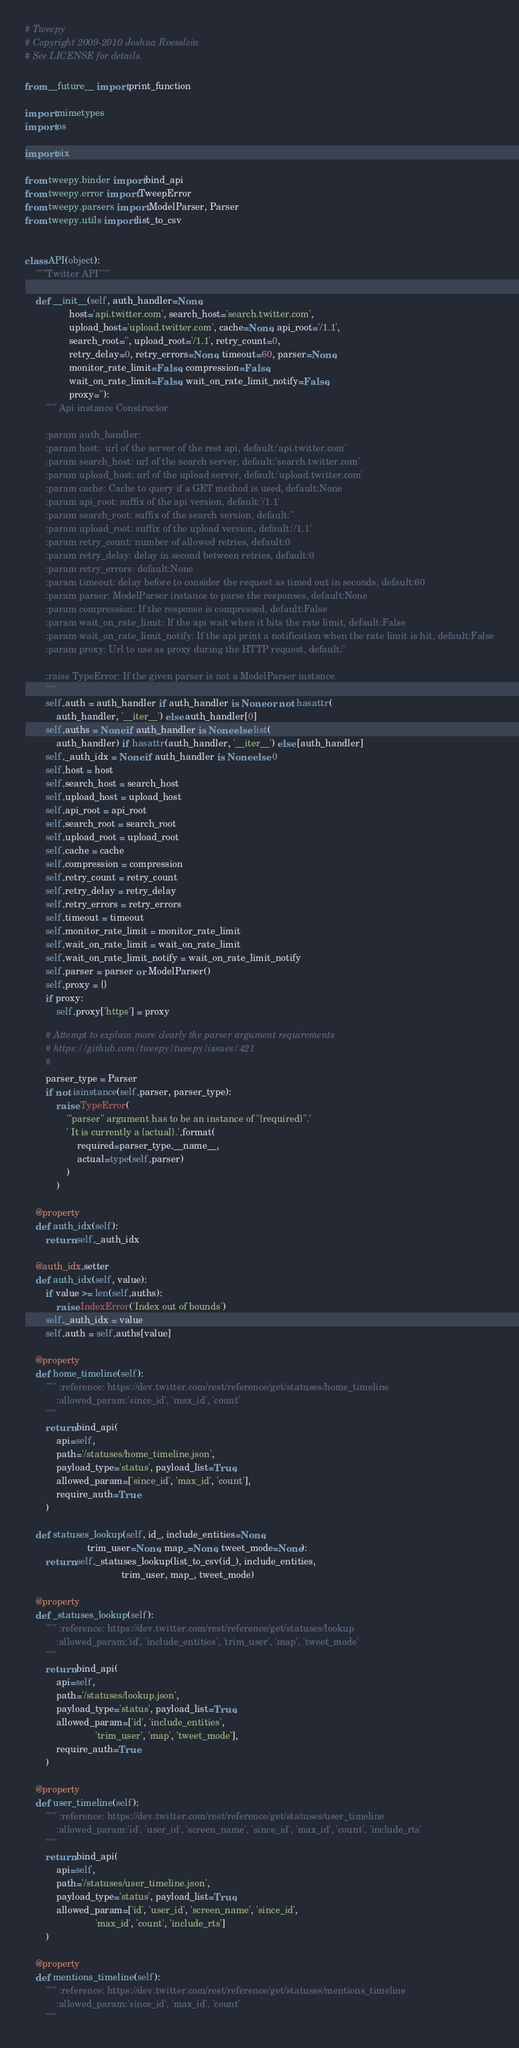<code> <loc_0><loc_0><loc_500><loc_500><_Python_># Tweepy
# Copyright 2009-2010 Joshua Roesslein
# See LICENSE for details.

from __future__ import print_function

import mimetypes
import os

import six

from tweepy.binder import bind_api
from tweepy.error import TweepError
from tweepy.parsers import ModelParser, Parser
from tweepy.utils import list_to_csv


class API(object):
    """Twitter API"""

    def __init__(self, auth_handler=None,
                 host='api.twitter.com', search_host='search.twitter.com',
                 upload_host='upload.twitter.com', cache=None, api_root='/1.1',
                 search_root='', upload_root='/1.1', retry_count=0,
                 retry_delay=0, retry_errors=None, timeout=60, parser=None,
                 monitor_rate_limit=False, compression=False,
                 wait_on_rate_limit=False, wait_on_rate_limit_notify=False,
                 proxy=''):
        """ Api instance Constructor

        :param auth_handler:
        :param host:  url of the server of the rest api, default:'api.twitter.com'
        :param search_host: url of the search server, default:'search.twitter.com'
        :param upload_host: url of the upload server, default:'upload.twitter.com'
        :param cache: Cache to query if a GET method is used, default:None
        :param api_root: suffix of the api version, default:'/1.1'
        :param search_root: suffix of the search version, default:''
        :param upload_root: suffix of the upload version, default:'/1.1'
        :param retry_count: number of allowed retries, default:0
        :param retry_delay: delay in second between retries, default:0
        :param retry_errors: default:None
        :param timeout: delay before to consider the request as timed out in seconds, default:60
        :param parser: ModelParser instance to parse the responses, default:None
        :param compression: If the response is compressed, default:False
        :param wait_on_rate_limit: If the api wait when it hits the rate limit, default:False
        :param wait_on_rate_limit_notify: If the api print a notification when the rate limit is hit, default:False
        :param proxy: Url to use as proxy during the HTTP request, default:''

        :raise TypeError: If the given parser is not a ModelParser instance.
        """
        self.auth = auth_handler if auth_handler is None or not hasattr(
            auth_handler, '__iter__') else auth_handler[0]
        self.auths = None if auth_handler is None else list(
            auth_handler) if hasattr(auth_handler, '__iter__') else [auth_handler]
        self._auth_idx = None if auth_handler is None else 0
        self.host = host
        self.search_host = search_host
        self.upload_host = upload_host
        self.api_root = api_root
        self.search_root = search_root
        self.upload_root = upload_root
        self.cache = cache
        self.compression = compression
        self.retry_count = retry_count
        self.retry_delay = retry_delay
        self.retry_errors = retry_errors
        self.timeout = timeout
        self.monitor_rate_limit = monitor_rate_limit
        self.wait_on_rate_limit = wait_on_rate_limit
        self.wait_on_rate_limit_notify = wait_on_rate_limit_notify
        self.parser = parser or ModelParser()
        self.proxy = {}
        if proxy:
            self.proxy['https'] = proxy

        # Attempt to explain more clearly the parser argument requirements
        # https://github.com/tweepy/tweepy/issues/421
        #
        parser_type = Parser
        if not isinstance(self.parser, parser_type):
            raise TypeError(
                '"parser" argument has to be an instance of "{required}".'
                ' It is currently a {actual}.'.format(
                    required=parser_type.__name__,
                    actual=type(self.parser)
                )
            )

    @property
    def auth_idx(self):
        return self._auth_idx

    @auth_idx.setter
    def auth_idx(self, value):
        if value >= len(self.auths):
            raise IndexError('Index out of bounds')
        self._auth_idx = value
        self.auth = self.auths[value]

    @property
    def home_timeline(self):
        """ :reference: https://dev.twitter.com/rest/reference/get/statuses/home_timeline
            :allowed_param:'since_id', 'max_id', 'count'
        """
        return bind_api(
            api=self,
            path='/statuses/home_timeline.json',
            payload_type='status', payload_list=True,
            allowed_param=['since_id', 'max_id', 'count'],
            require_auth=True
        )

    def statuses_lookup(self, id_, include_entities=None,
                        trim_user=None, map_=None, tweet_mode=None):
        return self._statuses_lookup(list_to_csv(id_), include_entities,
                                     trim_user, map_, tweet_mode)

    @property
    def _statuses_lookup(self):
        """ :reference: https://dev.twitter.com/rest/reference/get/statuses/lookup
            :allowed_param:'id', 'include_entities', 'trim_user', 'map', 'tweet_mode'
        """
        return bind_api(
            api=self,
            path='/statuses/lookup.json',
            payload_type='status', payload_list=True,
            allowed_param=['id', 'include_entities',
                           'trim_user', 'map', 'tweet_mode'],
            require_auth=True
        )

    @property
    def user_timeline(self):
        """ :reference: https://dev.twitter.com/rest/reference/get/statuses/user_timeline
            :allowed_param:'id', 'user_id', 'screen_name', 'since_id', 'max_id', 'count', 'include_rts'
        """
        return bind_api(
            api=self,
            path='/statuses/user_timeline.json',
            payload_type='status', payload_list=True,
            allowed_param=['id', 'user_id', 'screen_name', 'since_id',
                           'max_id', 'count', 'include_rts']
        )

    @property
    def mentions_timeline(self):
        """ :reference: https://dev.twitter.com/rest/reference/get/statuses/mentions_timeline
            :allowed_param:'since_id', 'max_id', 'count'
        """</code> 